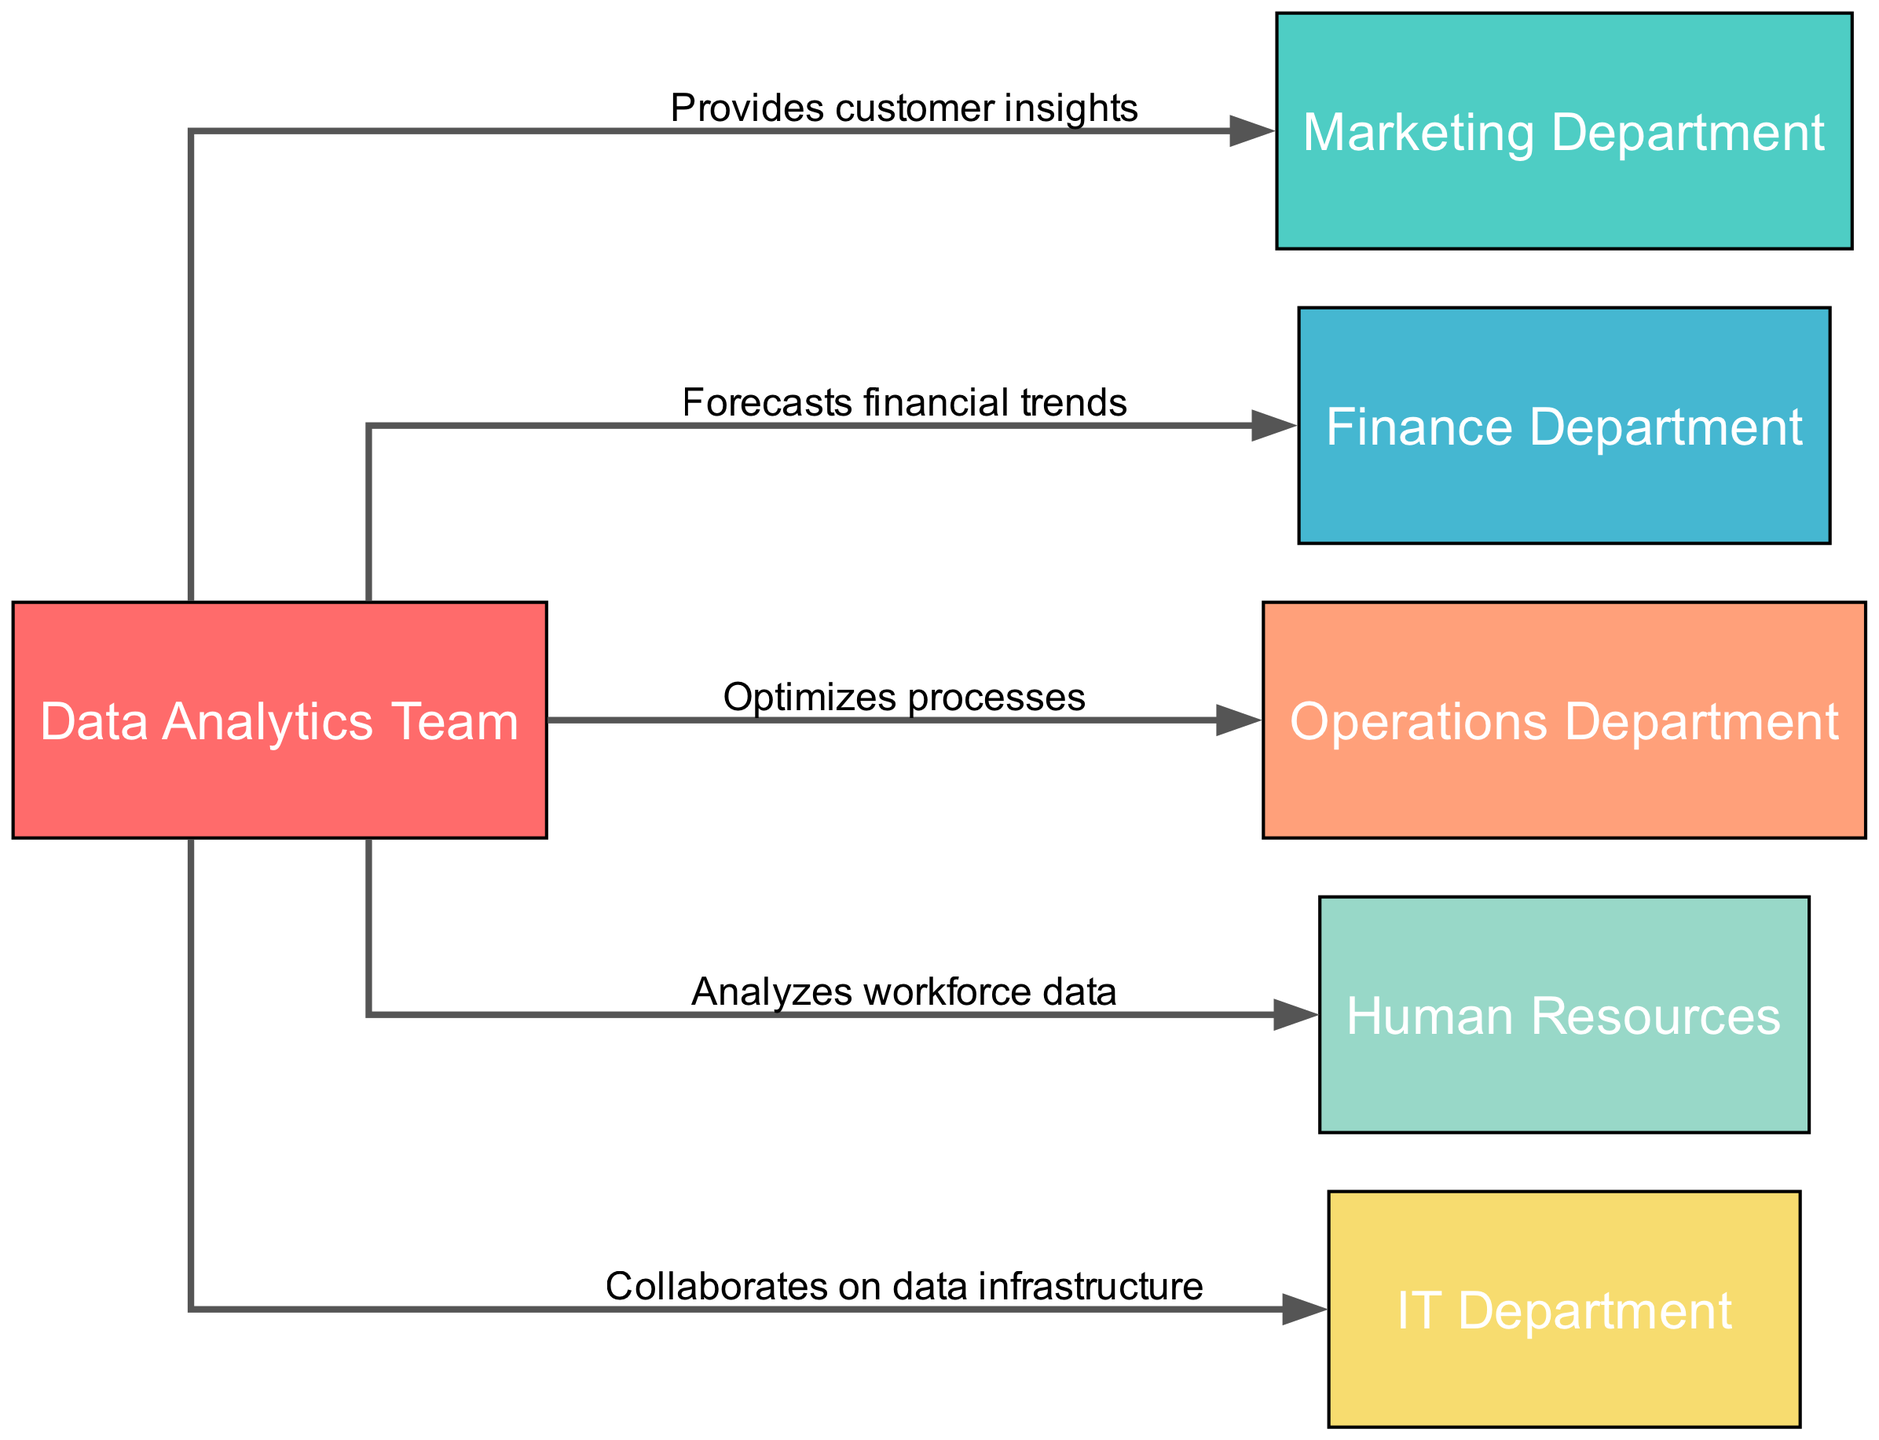What is the main team depicted in the diagram? The diagram clearly identifies the "Data Analytics Team" as the central node, denoting its role in the organization.
Answer: Data Analytics Team How many departments are illustrated in the diagram? By counting the nodes presented, we identify a total of six departments connected to the Data Analytics Team.
Answer: Six Which department does the Data Analytics Team provide customer insights to? The edge from "Data Analytics Team" to "Marketing Department" specifies that customer insights are provided directly to the marketing team's operational needs.
Answer: Marketing Department What type of relationship exists between the Data Analytics Team and the Finance Department? The diagram shows an edge labeled "Forecasts financial trends" indicating a supportive relationship where the Data Analytics Team aids in financial forecasting.
Answer: Forecasts financial trends How many collaborations are shown between the Data Analytics Team and other departments? The diagram provides five distinct edges, each representing a unique collaboration or interaction with various departments, confirming that there are multiple ways the teams work together.
Answer: Five Which department collaborates with the Data Analytics Team on data infrastructure? The label on the edge connecting "Data Analytics Team" to "IT Department" explicitly mentions collaboration on data infrastructure as a key interaction.
Answer: IT Department Which department receives analysis of workforce data from the Data Analytics Team? The edge connecting the Data Analytics Team to Human Resources indicates that it provides analytics on workforce data, fulfilling HR's need for data-driven insights in managing personnel.
Answer: Human Resources What is the primary function communicated by the connection to the Operations Department? The diagram states that the Data Analytics Team "Optimizes processes" for the Operational department, revealing their role in improving operational efficiency.
Answer: Optimizes processes 